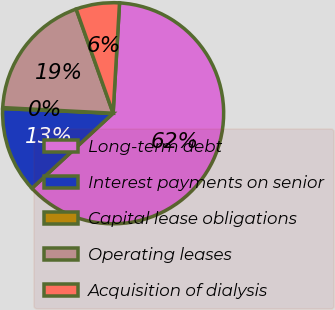Convert chart to OTSL. <chart><loc_0><loc_0><loc_500><loc_500><pie_chart><fcel>Long-term debt<fcel>Interest payments on senior<fcel>Capital lease obligations<fcel>Operating leases<fcel>Acquisition of dialysis<nl><fcel>62.2%<fcel>12.55%<fcel>0.14%<fcel>18.76%<fcel>6.35%<nl></chart> 